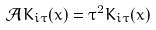Convert formula to latex. <formula><loc_0><loc_0><loc_500><loc_500>\mathcal { A } K _ { i \tau } ( x ) = \tau ^ { 2 } K _ { i \tau } ( x )</formula> 